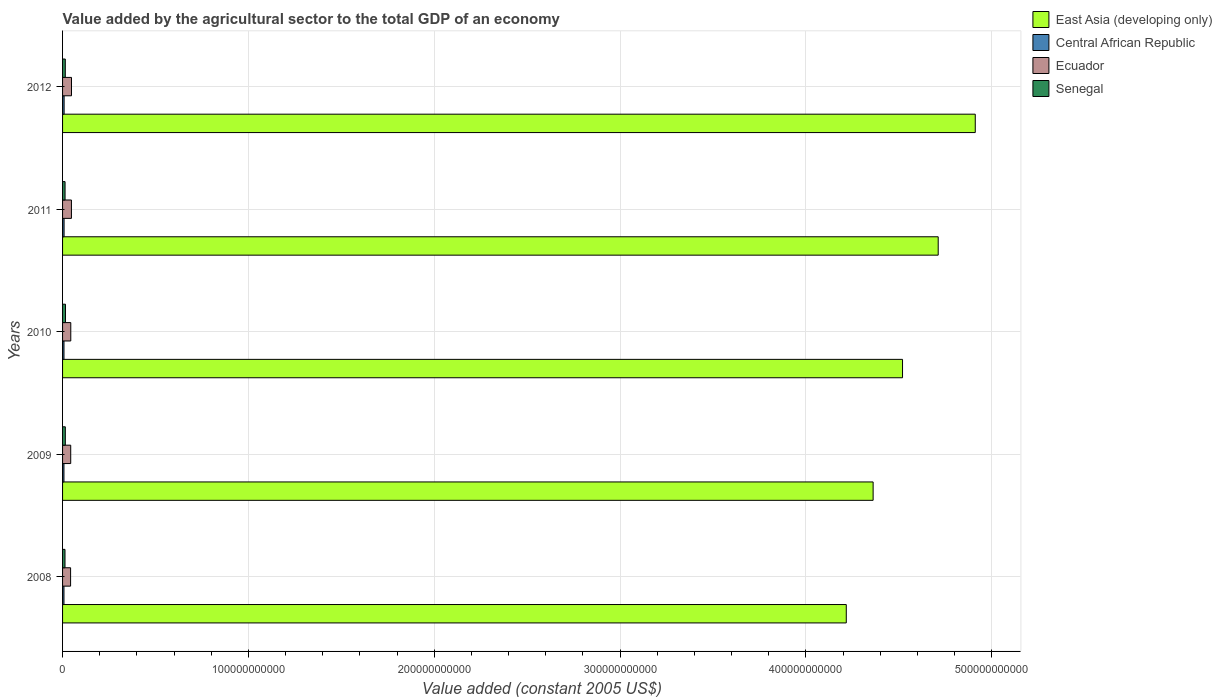Are the number of bars per tick equal to the number of legend labels?
Make the answer very short. Yes. Are the number of bars on each tick of the Y-axis equal?
Your answer should be compact. Yes. What is the label of the 1st group of bars from the top?
Your answer should be compact. 2012. What is the value added by the agricultural sector in Senegal in 2010?
Your answer should be very brief. 1.57e+09. Across all years, what is the maximum value added by the agricultural sector in Central African Republic?
Give a very brief answer. 8.34e+08. Across all years, what is the minimum value added by the agricultural sector in Ecuador?
Offer a very short reply. 4.32e+09. What is the total value added by the agricultural sector in Senegal in the graph?
Your answer should be very brief. 7.18e+09. What is the difference between the value added by the agricultural sector in Ecuador in 2008 and that in 2010?
Your response must be concise. -1.06e+08. What is the difference between the value added by the agricultural sector in Senegal in 2010 and the value added by the agricultural sector in Ecuador in 2009?
Provide a short and direct response. -2.82e+09. What is the average value added by the agricultural sector in East Asia (developing only) per year?
Keep it short and to the point. 4.54e+11. In the year 2009, what is the difference between the value added by the agricultural sector in Senegal and value added by the agricultural sector in Central African Republic?
Ensure brevity in your answer.  7.36e+08. In how many years, is the value added by the agricultural sector in Central African Republic greater than 80000000000 US$?
Offer a very short reply. 0. What is the ratio of the value added by the agricultural sector in Senegal in 2011 to that in 2012?
Ensure brevity in your answer.  0.91. Is the difference between the value added by the agricultural sector in Senegal in 2008 and 2012 greater than the difference between the value added by the agricultural sector in Central African Republic in 2008 and 2012?
Keep it short and to the point. No. What is the difference between the highest and the second highest value added by the agricultural sector in East Asia (developing only)?
Give a very brief answer. 1.99e+1. What is the difference between the highest and the lowest value added by the agricultural sector in Senegal?
Provide a succinct answer. 2.57e+08. In how many years, is the value added by the agricultural sector in East Asia (developing only) greater than the average value added by the agricultural sector in East Asia (developing only) taken over all years?
Give a very brief answer. 2. Is the sum of the value added by the agricultural sector in Ecuador in 2008 and 2009 greater than the maximum value added by the agricultural sector in Central African Republic across all years?
Offer a very short reply. Yes. What does the 3rd bar from the top in 2011 represents?
Give a very brief answer. Central African Republic. What does the 3rd bar from the bottom in 2009 represents?
Your response must be concise. Ecuador. What is the difference between two consecutive major ticks on the X-axis?
Your response must be concise. 1.00e+11. Are the values on the major ticks of X-axis written in scientific E-notation?
Make the answer very short. No. Does the graph contain any zero values?
Give a very brief answer. No. Where does the legend appear in the graph?
Ensure brevity in your answer.  Top right. How are the legend labels stacked?
Give a very brief answer. Vertical. What is the title of the graph?
Keep it short and to the point. Value added by the agricultural sector to the total GDP of an economy. Does "Brazil" appear as one of the legend labels in the graph?
Ensure brevity in your answer.  No. What is the label or title of the X-axis?
Your answer should be compact. Value added (constant 2005 US$). What is the label or title of the Y-axis?
Provide a short and direct response. Years. What is the Value added (constant 2005 US$) of East Asia (developing only) in 2008?
Provide a succinct answer. 4.22e+11. What is the Value added (constant 2005 US$) in Central African Republic in 2008?
Provide a succinct answer. 7.54e+08. What is the Value added (constant 2005 US$) in Ecuador in 2008?
Offer a terse response. 4.32e+09. What is the Value added (constant 2005 US$) in Senegal in 2008?
Make the answer very short. 1.31e+09. What is the Value added (constant 2005 US$) in East Asia (developing only) in 2009?
Your response must be concise. 4.36e+11. What is the Value added (constant 2005 US$) of Central African Republic in 2009?
Your response must be concise. 7.48e+08. What is the Value added (constant 2005 US$) of Ecuador in 2009?
Ensure brevity in your answer.  4.39e+09. What is the Value added (constant 2005 US$) in Senegal in 2009?
Offer a terse response. 1.48e+09. What is the Value added (constant 2005 US$) of East Asia (developing only) in 2010?
Give a very brief answer. 4.52e+11. What is the Value added (constant 2005 US$) of Central African Republic in 2010?
Give a very brief answer. 7.63e+08. What is the Value added (constant 2005 US$) in Ecuador in 2010?
Make the answer very short. 4.42e+09. What is the Value added (constant 2005 US$) of Senegal in 2010?
Your answer should be very brief. 1.57e+09. What is the Value added (constant 2005 US$) in East Asia (developing only) in 2011?
Provide a succinct answer. 4.71e+11. What is the Value added (constant 2005 US$) of Central African Republic in 2011?
Your response must be concise. 8.12e+08. What is the Value added (constant 2005 US$) in Ecuador in 2011?
Keep it short and to the point. 4.77e+09. What is the Value added (constant 2005 US$) in Senegal in 2011?
Your response must be concise. 1.34e+09. What is the Value added (constant 2005 US$) in East Asia (developing only) in 2012?
Provide a succinct answer. 4.91e+11. What is the Value added (constant 2005 US$) of Central African Republic in 2012?
Ensure brevity in your answer.  8.34e+08. What is the Value added (constant 2005 US$) of Ecuador in 2012?
Your answer should be very brief. 4.81e+09. What is the Value added (constant 2005 US$) in Senegal in 2012?
Your response must be concise. 1.47e+09. Across all years, what is the maximum Value added (constant 2005 US$) in East Asia (developing only)?
Provide a succinct answer. 4.91e+11. Across all years, what is the maximum Value added (constant 2005 US$) in Central African Republic?
Provide a succinct answer. 8.34e+08. Across all years, what is the maximum Value added (constant 2005 US$) in Ecuador?
Provide a short and direct response. 4.81e+09. Across all years, what is the maximum Value added (constant 2005 US$) of Senegal?
Give a very brief answer. 1.57e+09. Across all years, what is the minimum Value added (constant 2005 US$) in East Asia (developing only)?
Offer a very short reply. 4.22e+11. Across all years, what is the minimum Value added (constant 2005 US$) in Central African Republic?
Ensure brevity in your answer.  7.48e+08. Across all years, what is the minimum Value added (constant 2005 US$) in Ecuador?
Your answer should be very brief. 4.32e+09. Across all years, what is the minimum Value added (constant 2005 US$) of Senegal?
Your response must be concise. 1.31e+09. What is the total Value added (constant 2005 US$) in East Asia (developing only) in the graph?
Offer a very short reply. 2.27e+12. What is the total Value added (constant 2005 US$) of Central African Republic in the graph?
Offer a very short reply. 3.91e+09. What is the total Value added (constant 2005 US$) in Ecuador in the graph?
Offer a terse response. 2.27e+1. What is the total Value added (constant 2005 US$) in Senegal in the graph?
Offer a terse response. 7.18e+09. What is the difference between the Value added (constant 2005 US$) in East Asia (developing only) in 2008 and that in 2009?
Give a very brief answer. -1.45e+1. What is the difference between the Value added (constant 2005 US$) of Central African Republic in 2008 and that in 2009?
Keep it short and to the point. 6.68e+06. What is the difference between the Value added (constant 2005 US$) of Ecuador in 2008 and that in 2009?
Keep it short and to the point. -7.40e+07. What is the difference between the Value added (constant 2005 US$) in Senegal in 2008 and that in 2009?
Make the answer very short. -1.71e+08. What is the difference between the Value added (constant 2005 US$) in East Asia (developing only) in 2008 and that in 2010?
Provide a short and direct response. -3.03e+1. What is the difference between the Value added (constant 2005 US$) of Central African Republic in 2008 and that in 2010?
Give a very brief answer. -8.57e+06. What is the difference between the Value added (constant 2005 US$) in Ecuador in 2008 and that in 2010?
Offer a terse response. -1.06e+08. What is the difference between the Value added (constant 2005 US$) of Senegal in 2008 and that in 2010?
Give a very brief answer. -2.57e+08. What is the difference between the Value added (constant 2005 US$) of East Asia (developing only) in 2008 and that in 2011?
Ensure brevity in your answer.  -4.95e+1. What is the difference between the Value added (constant 2005 US$) in Central African Republic in 2008 and that in 2011?
Give a very brief answer. -5.80e+07. What is the difference between the Value added (constant 2005 US$) of Ecuador in 2008 and that in 2011?
Your response must be concise. -4.58e+08. What is the difference between the Value added (constant 2005 US$) of Senegal in 2008 and that in 2011?
Provide a succinct answer. -3.03e+07. What is the difference between the Value added (constant 2005 US$) in East Asia (developing only) in 2008 and that in 2012?
Make the answer very short. -6.94e+1. What is the difference between the Value added (constant 2005 US$) in Central African Republic in 2008 and that in 2012?
Ensure brevity in your answer.  -7.95e+07. What is the difference between the Value added (constant 2005 US$) in Ecuador in 2008 and that in 2012?
Provide a succinct answer. -4.95e+08. What is the difference between the Value added (constant 2005 US$) of Senegal in 2008 and that in 2012?
Your answer should be very brief. -1.59e+08. What is the difference between the Value added (constant 2005 US$) of East Asia (developing only) in 2009 and that in 2010?
Your answer should be compact. -1.58e+1. What is the difference between the Value added (constant 2005 US$) of Central African Republic in 2009 and that in 2010?
Your answer should be very brief. -1.53e+07. What is the difference between the Value added (constant 2005 US$) of Ecuador in 2009 and that in 2010?
Offer a terse response. -3.25e+07. What is the difference between the Value added (constant 2005 US$) of Senegal in 2009 and that in 2010?
Your response must be concise. -8.63e+07. What is the difference between the Value added (constant 2005 US$) in East Asia (developing only) in 2009 and that in 2011?
Give a very brief answer. -3.50e+1. What is the difference between the Value added (constant 2005 US$) of Central African Republic in 2009 and that in 2011?
Make the answer very short. -6.46e+07. What is the difference between the Value added (constant 2005 US$) of Ecuador in 2009 and that in 2011?
Keep it short and to the point. -3.84e+08. What is the difference between the Value added (constant 2005 US$) in Senegal in 2009 and that in 2011?
Your answer should be compact. 1.41e+08. What is the difference between the Value added (constant 2005 US$) in East Asia (developing only) in 2009 and that in 2012?
Your answer should be very brief. -5.50e+1. What is the difference between the Value added (constant 2005 US$) in Central African Republic in 2009 and that in 2012?
Your response must be concise. -8.62e+07. What is the difference between the Value added (constant 2005 US$) of Ecuador in 2009 and that in 2012?
Your response must be concise. -4.21e+08. What is the difference between the Value added (constant 2005 US$) of Senegal in 2009 and that in 2012?
Your answer should be very brief. 1.23e+07. What is the difference between the Value added (constant 2005 US$) in East Asia (developing only) in 2010 and that in 2011?
Keep it short and to the point. -1.92e+1. What is the difference between the Value added (constant 2005 US$) of Central African Republic in 2010 and that in 2011?
Keep it short and to the point. -4.94e+07. What is the difference between the Value added (constant 2005 US$) of Ecuador in 2010 and that in 2011?
Your answer should be very brief. -3.51e+08. What is the difference between the Value added (constant 2005 US$) in Senegal in 2010 and that in 2011?
Your response must be concise. 2.27e+08. What is the difference between the Value added (constant 2005 US$) in East Asia (developing only) in 2010 and that in 2012?
Your response must be concise. -3.91e+1. What is the difference between the Value added (constant 2005 US$) in Central African Republic in 2010 and that in 2012?
Offer a terse response. -7.10e+07. What is the difference between the Value added (constant 2005 US$) in Ecuador in 2010 and that in 2012?
Offer a terse response. -3.88e+08. What is the difference between the Value added (constant 2005 US$) in Senegal in 2010 and that in 2012?
Your answer should be very brief. 9.87e+07. What is the difference between the Value added (constant 2005 US$) of East Asia (developing only) in 2011 and that in 2012?
Give a very brief answer. -1.99e+1. What is the difference between the Value added (constant 2005 US$) of Central African Republic in 2011 and that in 2012?
Provide a short and direct response. -2.16e+07. What is the difference between the Value added (constant 2005 US$) in Ecuador in 2011 and that in 2012?
Make the answer very short. -3.70e+07. What is the difference between the Value added (constant 2005 US$) in Senegal in 2011 and that in 2012?
Give a very brief answer. -1.28e+08. What is the difference between the Value added (constant 2005 US$) in East Asia (developing only) in 2008 and the Value added (constant 2005 US$) in Central African Republic in 2009?
Provide a succinct answer. 4.21e+11. What is the difference between the Value added (constant 2005 US$) in East Asia (developing only) in 2008 and the Value added (constant 2005 US$) in Ecuador in 2009?
Your answer should be compact. 4.17e+11. What is the difference between the Value added (constant 2005 US$) in East Asia (developing only) in 2008 and the Value added (constant 2005 US$) in Senegal in 2009?
Make the answer very short. 4.20e+11. What is the difference between the Value added (constant 2005 US$) in Central African Republic in 2008 and the Value added (constant 2005 US$) in Ecuador in 2009?
Ensure brevity in your answer.  -3.64e+09. What is the difference between the Value added (constant 2005 US$) of Central African Republic in 2008 and the Value added (constant 2005 US$) of Senegal in 2009?
Provide a short and direct response. -7.29e+08. What is the difference between the Value added (constant 2005 US$) of Ecuador in 2008 and the Value added (constant 2005 US$) of Senegal in 2009?
Keep it short and to the point. 2.83e+09. What is the difference between the Value added (constant 2005 US$) of East Asia (developing only) in 2008 and the Value added (constant 2005 US$) of Central African Republic in 2010?
Ensure brevity in your answer.  4.21e+11. What is the difference between the Value added (constant 2005 US$) of East Asia (developing only) in 2008 and the Value added (constant 2005 US$) of Ecuador in 2010?
Offer a very short reply. 4.17e+11. What is the difference between the Value added (constant 2005 US$) in East Asia (developing only) in 2008 and the Value added (constant 2005 US$) in Senegal in 2010?
Ensure brevity in your answer.  4.20e+11. What is the difference between the Value added (constant 2005 US$) of Central African Republic in 2008 and the Value added (constant 2005 US$) of Ecuador in 2010?
Your response must be concise. -3.67e+09. What is the difference between the Value added (constant 2005 US$) in Central African Republic in 2008 and the Value added (constant 2005 US$) in Senegal in 2010?
Give a very brief answer. -8.15e+08. What is the difference between the Value added (constant 2005 US$) of Ecuador in 2008 and the Value added (constant 2005 US$) of Senegal in 2010?
Your response must be concise. 2.75e+09. What is the difference between the Value added (constant 2005 US$) in East Asia (developing only) in 2008 and the Value added (constant 2005 US$) in Central African Republic in 2011?
Offer a very short reply. 4.21e+11. What is the difference between the Value added (constant 2005 US$) in East Asia (developing only) in 2008 and the Value added (constant 2005 US$) in Ecuador in 2011?
Your answer should be compact. 4.17e+11. What is the difference between the Value added (constant 2005 US$) in East Asia (developing only) in 2008 and the Value added (constant 2005 US$) in Senegal in 2011?
Offer a very short reply. 4.20e+11. What is the difference between the Value added (constant 2005 US$) of Central African Republic in 2008 and the Value added (constant 2005 US$) of Ecuador in 2011?
Give a very brief answer. -4.02e+09. What is the difference between the Value added (constant 2005 US$) of Central African Republic in 2008 and the Value added (constant 2005 US$) of Senegal in 2011?
Your response must be concise. -5.88e+08. What is the difference between the Value added (constant 2005 US$) of Ecuador in 2008 and the Value added (constant 2005 US$) of Senegal in 2011?
Your answer should be very brief. 2.97e+09. What is the difference between the Value added (constant 2005 US$) of East Asia (developing only) in 2008 and the Value added (constant 2005 US$) of Central African Republic in 2012?
Ensure brevity in your answer.  4.21e+11. What is the difference between the Value added (constant 2005 US$) of East Asia (developing only) in 2008 and the Value added (constant 2005 US$) of Ecuador in 2012?
Ensure brevity in your answer.  4.17e+11. What is the difference between the Value added (constant 2005 US$) in East Asia (developing only) in 2008 and the Value added (constant 2005 US$) in Senegal in 2012?
Your response must be concise. 4.20e+11. What is the difference between the Value added (constant 2005 US$) in Central African Republic in 2008 and the Value added (constant 2005 US$) in Ecuador in 2012?
Your answer should be compact. -4.06e+09. What is the difference between the Value added (constant 2005 US$) in Central African Republic in 2008 and the Value added (constant 2005 US$) in Senegal in 2012?
Keep it short and to the point. -7.17e+08. What is the difference between the Value added (constant 2005 US$) in Ecuador in 2008 and the Value added (constant 2005 US$) in Senegal in 2012?
Provide a short and direct response. 2.85e+09. What is the difference between the Value added (constant 2005 US$) in East Asia (developing only) in 2009 and the Value added (constant 2005 US$) in Central African Republic in 2010?
Offer a very short reply. 4.35e+11. What is the difference between the Value added (constant 2005 US$) in East Asia (developing only) in 2009 and the Value added (constant 2005 US$) in Ecuador in 2010?
Your response must be concise. 4.32e+11. What is the difference between the Value added (constant 2005 US$) of East Asia (developing only) in 2009 and the Value added (constant 2005 US$) of Senegal in 2010?
Keep it short and to the point. 4.35e+11. What is the difference between the Value added (constant 2005 US$) of Central African Republic in 2009 and the Value added (constant 2005 US$) of Ecuador in 2010?
Your response must be concise. -3.68e+09. What is the difference between the Value added (constant 2005 US$) of Central African Republic in 2009 and the Value added (constant 2005 US$) of Senegal in 2010?
Ensure brevity in your answer.  -8.22e+08. What is the difference between the Value added (constant 2005 US$) of Ecuador in 2009 and the Value added (constant 2005 US$) of Senegal in 2010?
Make the answer very short. 2.82e+09. What is the difference between the Value added (constant 2005 US$) of East Asia (developing only) in 2009 and the Value added (constant 2005 US$) of Central African Republic in 2011?
Ensure brevity in your answer.  4.35e+11. What is the difference between the Value added (constant 2005 US$) of East Asia (developing only) in 2009 and the Value added (constant 2005 US$) of Ecuador in 2011?
Make the answer very short. 4.31e+11. What is the difference between the Value added (constant 2005 US$) of East Asia (developing only) in 2009 and the Value added (constant 2005 US$) of Senegal in 2011?
Your response must be concise. 4.35e+11. What is the difference between the Value added (constant 2005 US$) in Central African Republic in 2009 and the Value added (constant 2005 US$) in Ecuador in 2011?
Your answer should be very brief. -4.03e+09. What is the difference between the Value added (constant 2005 US$) in Central African Republic in 2009 and the Value added (constant 2005 US$) in Senegal in 2011?
Provide a succinct answer. -5.95e+08. What is the difference between the Value added (constant 2005 US$) of Ecuador in 2009 and the Value added (constant 2005 US$) of Senegal in 2011?
Your answer should be compact. 3.05e+09. What is the difference between the Value added (constant 2005 US$) of East Asia (developing only) in 2009 and the Value added (constant 2005 US$) of Central African Republic in 2012?
Your response must be concise. 4.35e+11. What is the difference between the Value added (constant 2005 US$) of East Asia (developing only) in 2009 and the Value added (constant 2005 US$) of Ecuador in 2012?
Provide a short and direct response. 4.31e+11. What is the difference between the Value added (constant 2005 US$) in East Asia (developing only) in 2009 and the Value added (constant 2005 US$) in Senegal in 2012?
Ensure brevity in your answer.  4.35e+11. What is the difference between the Value added (constant 2005 US$) in Central African Republic in 2009 and the Value added (constant 2005 US$) in Ecuador in 2012?
Provide a succinct answer. -4.06e+09. What is the difference between the Value added (constant 2005 US$) of Central African Republic in 2009 and the Value added (constant 2005 US$) of Senegal in 2012?
Your response must be concise. -7.23e+08. What is the difference between the Value added (constant 2005 US$) of Ecuador in 2009 and the Value added (constant 2005 US$) of Senegal in 2012?
Keep it short and to the point. 2.92e+09. What is the difference between the Value added (constant 2005 US$) in East Asia (developing only) in 2010 and the Value added (constant 2005 US$) in Central African Republic in 2011?
Offer a very short reply. 4.51e+11. What is the difference between the Value added (constant 2005 US$) of East Asia (developing only) in 2010 and the Value added (constant 2005 US$) of Ecuador in 2011?
Ensure brevity in your answer.  4.47e+11. What is the difference between the Value added (constant 2005 US$) of East Asia (developing only) in 2010 and the Value added (constant 2005 US$) of Senegal in 2011?
Your answer should be very brief. 4.51e+11. What is the difference between the Value added (constant 2005 US$) of Central African Republic in 2010 and the Value added (constant 2005 US$) of Ecuador in 2011?
Give a very brief answer. -4.01e+09. What is the difference between the Value added (constant 2005 US$) of Central African Republic in 2010 and the Value added (constant 2005 US$) of Senegal in 2011?
Keep it short and to the point. -5.80e+08. What is the difference between the Value added (constant 2005 US$) in Ecuador in 2010 and the Value added (constant 2005 US$) in Senegal in 2011?
Your answer should be very brief. 3.08e+09. What is the difference between the Value added (constant 2005 US$) of East Asia (developing only) in 2010 and the Value added (constant 2005 US$) of Central African Republic in 2012?
Provide a short and direct response. 4.51e+11. What is the difference between the Value added (constant 2005 US$) of East Asia (developing only) in 2010 and the Value added (constant 2005 US$) of Ecuador in 2012?
Your response must be concise. 4.47e+11. What is the difference between the Value added (constant 2005 US$) in East Asia (developing only) in 2010 and the Value added (constant 2005 US$) in Senegal in 2012?
Your answer should be very brief. 4.50e+11. What is the difference between the Value added (constant 2005 US$) in Central African Republic in 2010 and the Value added (constant 2005 US$) in Ecuador in 2012?
Ensure brevity in your answer.  -4.05e+09. What is the difference between the Value added (constant 2005 US$) of Central African Republic in 2010 and the Value added (constant 2005 US$) of Senegal in 2012?
Your answer should be very brief. -7.08e+08. What is the difference between the Value added (constant 2005 US$) in Ecuador in 2010 and the Value added (constant 2005 US$) in Senegal in 2012?
Your response must be concise. 2.95e+09. What is the difference between the Value added (constant 2005 US$) in East Asia (developing only) in 2011 and the Value added (constant 2005 US$) in Central African Republic in 2012?
Give a very brief answer. 4.70e+11. What is the difference between the Value added (constant 2005 US$) in East Asia (developing only) in 2011 and the Value added (constant 2005 US$) in Ecuador in 2012?
Your answer should be very brief. 4.66e+11. What is the difference between the Value added (constant 2005 US$) of East Asia (developing only) in 2011 and the Value added (constant 2005 US$) of Senegal in 2012?
Offer a very short reply. 4.70e+11. What is the difference between the Value added (constant 2005 US$) of Central African Republic in 2011 and the Value added (constant 2005 US$) of Ecuador in 2012?
Offer a very short reply. -4.00e+09. What is the difference between the Value added (constant 2005 US$) of Central African Republic in 2011 and the Value added (constant 2005 US$) of Senegal in 2012?
Your answer should be very brief. -6.59e+08. What is the difference between the Value added (constant 2005 US$) of Ecuador in 2011 and the Value added (constant 2005 US$) of Senegal in 2012?
Provide a short and direct response. 3.30e+09. What is the average Value added (constant 2005 US$) of East Asia (developing only) per year?
Your response must be concise. 4.54e+11. What is the average Value added (constant 2005 US$) in Central African Republic per year?
Offer a terse response. 7.82e+08. What is the average Value added (constant 2005 US$) of Ecuador per year?
Provide a succinct answer. 4.54e+09. What is the average Value added (constant 2005 US$) of Senegal per year?
Offer a terse response. 1.44e+09. In the year 2008, what is the difference between the Value added (constant 2005 US$) in East Asia (developing only) and Value added (constant 2005 US$) in Central African Republic?
Provide a short and direct response. 4.21e+11. In the year 2008, what is the difference between the Value added (constant 2005 US$) in East Asia (developing only) and Value added (constant 2005 US$) in Ecuador?
Keep it short and to the point. 4.17e+11. In the year 2008, what is the difference between the Value added (constant 2005 US$) in East Asia (developing only) and Value added (constant 2005 US$) in Senegal?
Provide a short and direct response. 4.20e+11. In the year 2008, what is the difference between the Value added (constant 2005 US$) in Central African Republic and Value added (constant 2005 US$) in Ecuador?
Your response must be concise. -3.56e+09. In the year 2008, what is the difference between the Value added (constant 2005 US$) of Central African Republic and Value added (constant 2005 US$) of Senegal?
Offer a very short reply. -5.58e+08. In the year 2008, what is the difference between the Value added (constant 2005 US$) of Ecuador and Value added (constant 2005 US$) of Senegal?
Provide a short and direct response. 3.00e+09. In the year 2009, what is the difference between the Value added (constant 2005 US$) of East Asia (developing only) and Value added (constant 2005 US$) of Central African Republic?
Offer a terse response. 4.35e+11. In the year 2009, what is the difference between the Value added (constant 2005 US$) of East Asia (developing only) and Value added (constant 2005 US$) of Ecuador?
Give a very brief answer. 4.32e+11. In the year 2009, what is the difference between the Value added (constant 2005 US$) of East Asia (developing only) and Value added (constant 2005 US$) of Senegal?
Provide a succinct answer. 4.35e+11. In the year 2009, what is the difference between the Value added (constant 2005 US$) in Central African Republic and Value added (constant 2005 US$) in Ecuador?
Offer a very short reply. -3.64e+09. In the year 2009, what is the difference between the Value added (constant 2005 US$) of Central African Republic and Value added (constant 2005 US$) of Senegal?
Provide a succinct answer. -7.36e+08. In the year 2009, what is the difference between the Value added (constant 2005 US$) in Ecuador and Value added (constant 2005 US$) in Senegal?
Provide a short and direct response. 2.91e+09. In the year 2010, what is the difference between the Value added (constant 2005 US$) in East Asia (developing only) and Value added (constant 2005 US$) in Central African Republic?
Offer a terse response. 4.51e+11. In the year 2010, what is the difference between the Value added (constant 2005 US$) of East Asia (developing only) and Value added (constant 2005 US$) of Ecuador?
Offer a terse response. 4.48e+11. In the year 2010, what is the difference between the Value added (constant 2005 US$) of East Asia (developing only) and Value added (constant 2005 US$) of Senegal?
Offer a very short reply. 4.50e+11. In the year 2010, what is the difference between the Value added (constant 2005 US$) in Central African Republic and Value added (constant 2005 US$) in Ecuador?
Your response must be concise. -3.66e+09. In the year 2010, what is the difference between the Value added (constant 2005 US$) of Central African Republic and Value added (constant 2005 US$) of Senegal?
Offer a terse response. -8.07e+08. In the year 2010, what is the difference between the Value added (constant 2005 US$) in Ecuador and Value added (constant 2005 US$) in Senegal?
Offer a very short reply. 2.85e+09. In the year 2011, what is the difference between the Value added (constant 2005 US$) of East Asia (developing only) and Value added (constant 2005 US$) of Central African Republic?
Offer a very short reply. 4.70e+11. In the year 2011, what is the difference between the Value added (constant 2005 US$) in East Asia (developing only) and Value added (constant 2005 US$) in Ecuador?
Ensure brevity in your answer.  4.66e+11. In the year 2011, what is the difference between the Value added (constant 2005 US$) in East Asia (developing only) and Value added (constant 2005 US$) in Senegal?
Your answer should be very brief. 4.70e+11. In the year 2011, what is the difference between the Value added (constant 2005 US$) of Central African Republic and Value added (constant 2005 US$) of Ecuador?
Your response must be concise. -3.96e+09. In the year 2011, what is the difference between the Value added (constant 2005 US$) in Central African Republic and Value added (constant 2005 US$) in Senegal?
Your response must be concise. -5.30e+08. In the year 2011, what is the difference between the Value added (constant 2005 US$) of Ecuador and Value added (constant 2005 US$) of Senegal?
Offer a terse response. 3.43e+09. In the year 2012, what is the difference between the Value added (constant 2005 US$) of East Asia (developing only) and Value added (constant 2005 US$) of Central African Republic?
Keep it short and to the point. 4.90e+11. In the year 2012, what is the difference between the Value added (constant 2005 US$) in East Asia (developing only) and Value added (constant 2005 US$) in Ecuador?
Keep it short and to the point. 4.86e+11. In the year 2012, what is the difference between the Value added (constant 2005 US$) in East Asia (developing only) and Value added (constant 2005 US$) in Senegal?
Make the answer very short. 4.90e+11. In the year 2012, what is the difference between the Value added (constant 2005 US$) in Central African Republic and Value added (constant 2005 US$) in Ecuador?
Provide a short and direct response. -3.98e+09. In the year 2012, what is the difference between the Value added (constant 2005 US$) in Central African Republic and Value added (constant 2005 US$) in Senegal?
Your response must be concise. -6.37e+08. In the year 2012, what is the difference between the Value added (constant 2005 US$) of Ecuador and Value added (constant 2005 US$) of Senegal?
Ensure brevity in your answer.  3.34e+09. What is the ratio of the Value added (constant 2005 US$) in East Asia (developing only) in 2008 to that in 2009?
Your response must be concise. 0.97. What is the ratio of the Value added (constant 2005 US$) in Central African Republic in 2008 to that in 2009?
Your answer should be very brief. 1.01. What is the ratio of the Value added (constant 2005 US$) of Ecuador in 2008 to that in 2009?
Give a very brief answer. 0.98. What is the ratio of the Value added (constant 2005 US$) in Senegal in 2008 to that in 2009?
Give a very brief answer. 0.88. What is the ratio of the Value added (constant 2005 US$) of East Asia (developing only) in 2008 to that in 2010?
Provide a short and direct response. 0.93. What is the ratio of the Value added (constant 2005 US$) in Ecuador in 2008 to that in 2010?
Keep it short and to the point. 0.98. What is the ratio of the Value added (constant 2005 US$) in Senegal in 2008 to that in 2010?
Provide a short and direct response. 0.84. What is the ratio of the Value added (constant 2005 US$) in East Asia (developing only) in 2008 to that in 2011?
Your response must be concise. 0.9. What is the ratio of the Value added (constant 2005 US$) of Central African Republic in 2008 to that in 2011?
Provide a short and direct response. 0.93. What is the ratio of the Value added (constant 2005 US$) in Ecuador in 2008 to that in 2011?
Offer a terse response. 0.9. What is the ratio of the Value added (constant 2005 US$) in Senegal in 2008 to that in 2011?
Your response must be concise. 0.98. What is the ratio of the Value added (constant 2005 US$) in East Asia (developing only) in 2008 to that in 2012?
Your response must be concise. 0.86. What is the ratio of the Value added (constant 2005 US$) in Central African Republic in 2008 to that in 2012?
Offer a terse response. 0.9. What is the ratio of the Value added (constant 2005 US$) of Ecuador in 2008 to that in 2012?
Provide a succinct answer. 0.9. What is the ratio of the Value added (constant 2005 US$) in Senegal in 2008 to that in 2012?
Ensure brevity in your answer.  0.89. What is the ratio of the Value added (constant 2005 US$) in East Asia (developing only) in 2009 to that in 2010?
Ensure brevity in your answer.  0.96. What is the ratio of the Value added (constant 2005 US$) in Ecuador in 2009 to that in 2010?
Your answer should be compact. 0.99. What is the ratio of the Value added (constant 2005 US$) in Senegal in 2009 to that in 2010?
Your response must be concise. 0.94. What is the ratio of the Value added (constant 2005 US$) in East Asia (developing only) in 2009 to that in 2011?
Provide a short and direct response. 0.93. What is the ratio of the Value added (constant 2005 US$) in Central African Republic in 2009 to that in 2011?
Offer a terse response. 0.92. What is the ratio of the Value added (constant 2005 US$) in Ecuador in 2009 to that in 2011?
Make the answer very short. 0.92. What is the ratio of the Value added (constant 2005 US$) in Senegal in 2009 to that in 2011?
Ensure brevity in your answer.  1.1. What is the ratio of the Value added (constant 2005 US$) in East Asia (developing only) in 2009 to that in 2012?
Provide a succinct answer. 0.89. What is the ratio of the Value added (constant 2005 US$) of Central African Republic in 2009 to that in 2012?
Give a very brief answer. 0.9. What is the ratio of the Value added (constant 2005 US$) of Ecuador in 2009 to that in 2012?
Your response must be concise. 0.91. What is the ratio of the Value added (constant 2005 US$) in Senegal in 2009 to that in 2012?
Provide a short and direct response. 1.01. What is the ratio of the Value added (constant 2005 US$) in East Asia (developing only) in 2010 to that in 2011?
Your answer should be very brief. 0.96. What is the ratio of the Value added (constant 2005 US$) in Central African Republic in 2010 to that in 2011?
Ensure brevity in your answer.  0.94. What is the ratio of the Value added (constant 2005 US$) of Ecuador in 2010 to that in 2011?
Your response must be concise. 0.93. What is the ratio of the Value added (constant 2005 US$) in Senegal in 2010 to that in 2011?
Offer a very short reply. 1.17. What is the ratio of the Value added (constant 2005 US$) in East Asia (developing only) in 2010 to that in 2012?
Your response must be concise. 0.92. What is the ratio of the Value added (constant 2005 US$) in Central African Republic in 2010 to that in 2012?
Keep it short and to the point. 0.91. What is the ratio of the Value added (constant 2005 US$) in Ecuador in 2010 to that in 2012?
Ensure brevity in your answer.  0.92. What is the ratio of the Value added (constant 2005 US$) of Senegal in 2010 to that in 2012?
Your answer should be very brief. 1.07. What is the ratio of the Value added (constant 2005 US$) of East Asia (developing only) in 2011 to that in 2012?
Your answer should be very brief. 0.96. What is the ratio of the Value added (constant 2005 US$) of Central African Republic in 2011 to that in 2012?
Offer a terse response. 0.97. What is the ratio of the Value added (constant 2005 US$) in Senegal in 2011 to that in 2012?
Give a very brief answer. 0.91. What is the difference between the highest and the second highest Value added (constant 2005 US$) of East Asia (developing only)?
Make the answer very short. 1.99e+1. What is the difference between the highest and the second highest Value added (constant 2005 US$) of Central African Republic?
Your answer should be compact. 2.16e+07. What is the difference between the highest and the second highest Value added (constant 2005 US$) of Ecuador?
Offer a terse response. 3.70e+07. What is the difference between the highest and the second highest Value added (constant 2005 US$) in Senegal?
Make the answer very short. 8.63e+07. What is the difference between the highest and the lowest Value added (constant 2005 US$) in East Asia (developing only)?
Keep it short and to the point. 6.94e+1. What is the difference between the highest and the lowest Value added (constant 2005 US$) of Central African Republic?
Ensure brevity in your answer.  8.62e+07. What is the difference between the highest and the lowest Value added (constant 2005 US$) in Ecuador?
Offer a very short reply. 4.95e+08. What is the difference between the highest and the lowest Value added (constant 2005 US$) of Senegal?
Offer a terse response. 2.57e+08. 